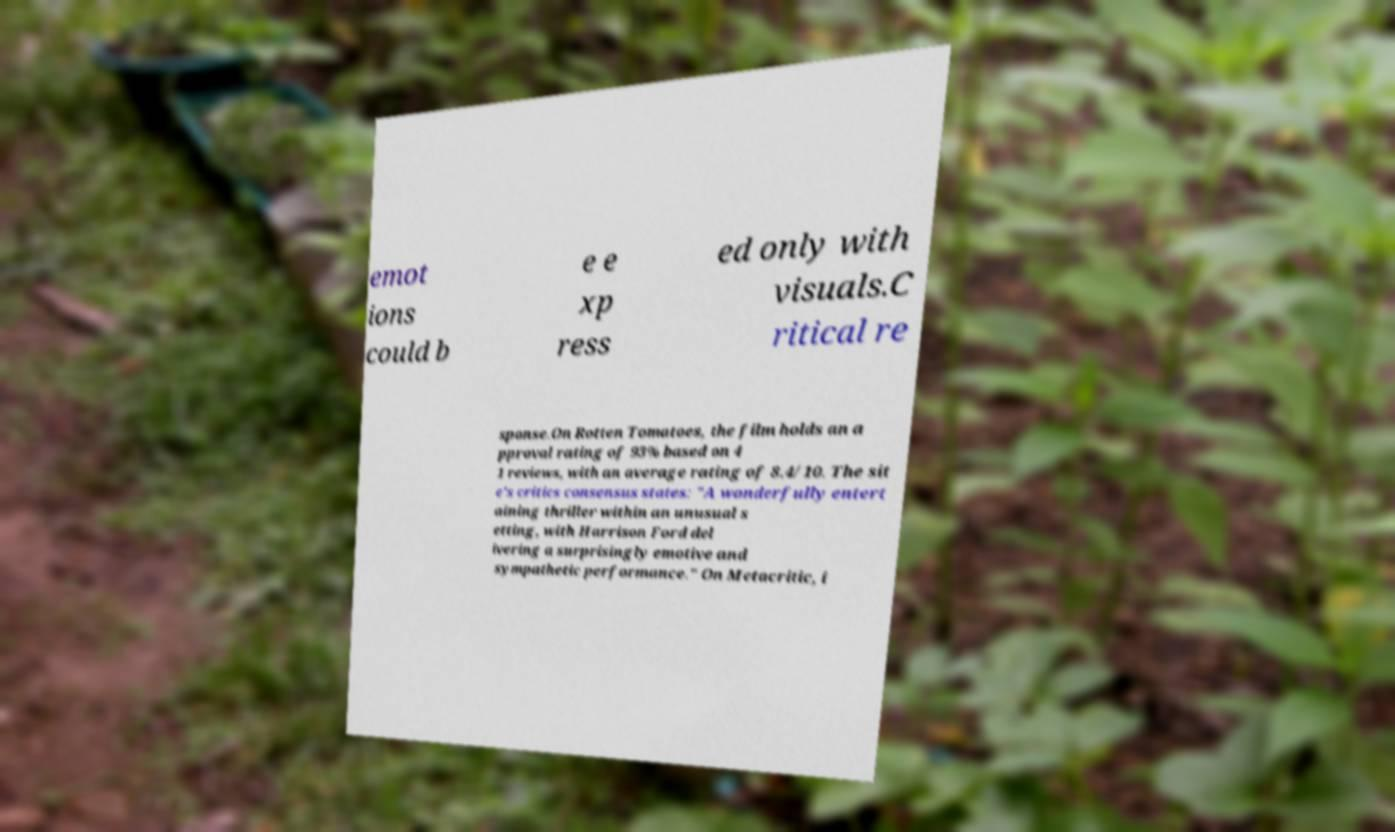Could you extract and type out the text from this image? emot ions could b e e xp ress ed only with visuals.C ritical re sponse.On Rotten Tomatoes, the film holds an a pproval rating of 93% based on 4 1 reviews, with an average rating of 8.4/10. The sit e's critics consensus states: "A wonderfully entert aining thriller within an unusual s etting, with Harrison Ford del ivering a surprisingly emotive and sympathetic performance." On Metacritic, i 